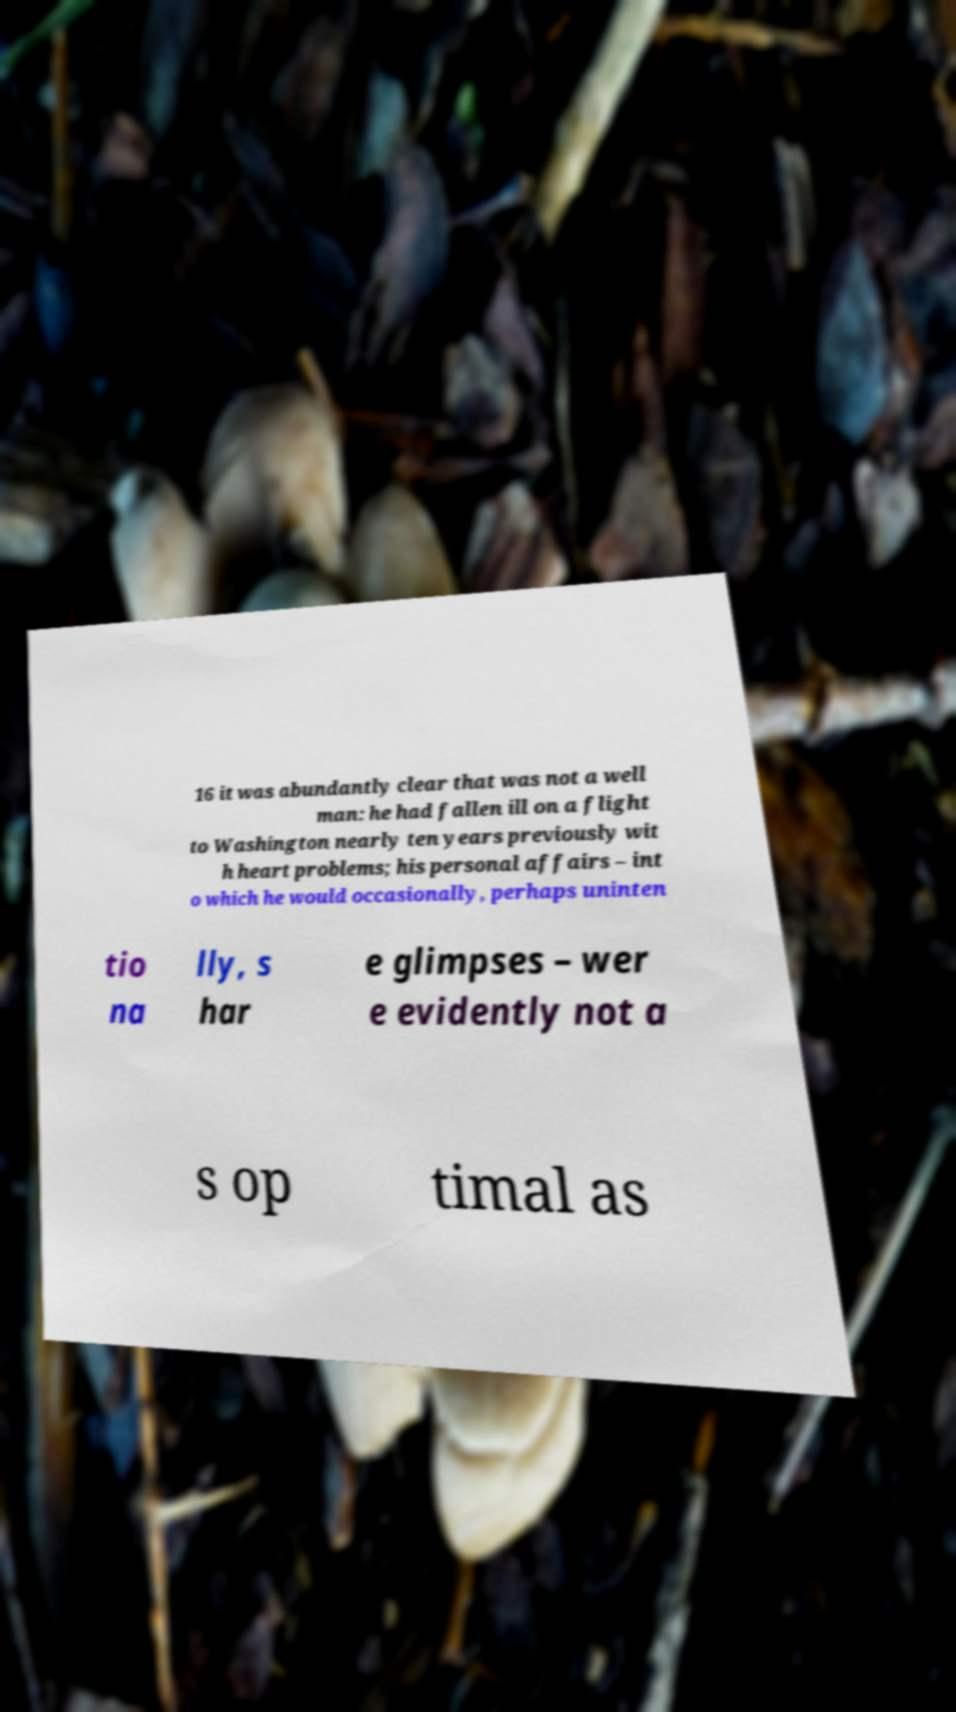I need the written content from this picture converted into text. Can you do that? 16 it was abundantly clear that was not a well man: he had fallen ill on a flight to Washington nearly ten years previously wit h heart problems; his personal affairs – int o which he would occasionally, perhaps uninten tio na lly, s har e glimpses – wer e evidently not a s op timal as 